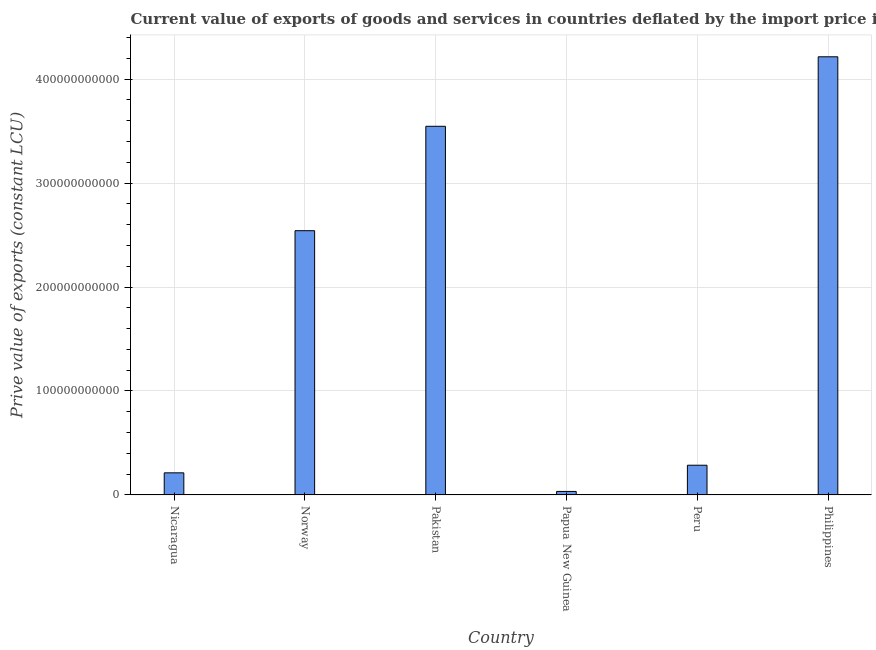What is the title of the graph?
Offer a very short reply. Current value of exports of goods and services in countries deflated by the import price index. What is the label or title of the X-axis?
Ensure brevity in your answer.  Country. What is the label or title of the Y-axis?
Offer a terse response. Prive value of exports (constant LCU). What is the price value of exports in Pakistan?
Make the answer very short. 3.55e+11. Across all countries, what is the maximum price value of exports?
Offer a very short reply. 4.22e+11. Across all countries, what is the minimum price value of exports?
Ensure brevity in your answer.  3.37e+09. In which country was the price value of exports minimum?
Offer a very short reply. Papua New Guinea. What is the sum of the price value of exports?
Provide a succinct answer. 1.08e+12. What is the difference between the price value of exports in Norway and Philippines?
Your response must be concise. -1.67e+11. What is the average price value of exports per country?
Provide a succinct answer. 1.81e+11. What is the median price value of exports?
Ensure brevity in your answer.  1.41e+11. In how many countries, is the price value of exports greater than 360000000000 LCU?
Provide a succinct answer. 1. What is the ratio of the price value of exports in Papua New Guinea to that in Philippines?
Provide a succinct answer. 0.01. What is the difference between the highest and the second highest price value of exports?
Offer a very short reply. 6.69e+1. What is the difference between the highest and the lowest price value of exports?
Offer a very short reply. 4.18e+11. In how many countries, is the price value of exports greater than the average price value of exports taken over all countries?
Ensure brevity in your answer.  3. How many bars are there?
Provide a succinct answer. 6. Are all the bars in the graph horizontal?
Provide a short and direct response. No. What is the difference between two consecutive major ticks on the Y-axis?
Keep it short and to the point. 1.00e+11. Are the values on the major ticks of Y-axis written in scientific E-notation?
Ensure brevity in your answer.  No. What is the Prive value of exports (constant LCU) of Nicaragua?
Your answer should be compact. 2.13e+1. What is the Prive value of exports (constant LCU) of Norway?
Provide a succinct answer. 2.54e+11. What is the Prive value of exports (constant LCU) in Pakistan?
Give a very brief answer. 3.55e+11. What is the Prive value of exports (constant LCU) in Papua New Guinea?
Make the answer very short. 3.37e+09. What is the Prive value of exports (constant LCU) of Peru?
Your answer should be compact. 2.86e+1. What is the Prive value of exports (constant LCU) in Philippines?
Your answer should be very brief. 4.22e+11. What is the difference between the Prive value of exports (constant LCU) in Nicaragua and Norway?
Offer a terse response. -2.33e+11. What is the difference between the Prive value of exports (constant LCU) in Nicaragua and Pakistan?
Provide a short and direct response. -3.33e+11. What is the difference between the Prive value of exports (constant LCU) in Nicaragua and Papua New Guinea?
Provide a succinct answer. 1.79e+1. What is the difference between the Prive value of exports (constant LCU) in Nicaragua and Peru?
Offer a very short reply. -7.32e+09. What is the difference between the Prive value of exports (constant LCU) in Nicaragua and Philippines?
Give a very brief answer. -4.00e+11. What is the difference between the Prive value of exports (constant LCU) in Norway and Pakistan?
Provide a succinct answer. -1.00e+11. What is the difference between the Prive value of exports (constant LCU) in Norway and Papua New Guinea?
Your answer should be compact. 2.51e+11. What is the difference between the Prive value of exports (constant LCU) in Norway and Peru?
Give a very brief answer. 2.26e+11. What is the difference between the Prive value of exports (constant LCU) in Norway and Philippines?
Offer a terse response. -1.67e+11. What is the difference between the Prive value of exports (constant LCU) in Pakistan and Papua New Guinea?
Offer a very short reply. 3.51e+11. What is the difference between the Prive value of exports (constant LCU) in Pakistan and Peru?
Your answer should be compact. 3.26e+11. What is the difference between the Prive value of exports (constant LCU) in Pakistan and Philippines?
Your answer should be compact. -6.69e+1. What is the difference between the Prive value of exports (constant LCU) in Papua New Guinea and Peru?
Offer a very short reply. -2.52e+1. What is the difference between the Prive value of exports (constant LCU) in Papua New Guinea and Philippines?
Offer a terse response. -4.18e+11. What is the difference between the Prive value of exports (constant LCU) in Peru and Philippines?
Your response must be concise. -3.93e+11. What is the ratio of the Prive value of exports (constant LCU) in Nicaragua to that in Norway?
Offer a terse response. 0.08. What is the ratio of the Prive value of exports (constant LCU) in Nicaragua to that in Pakistan?
Give a very brief answer. 0.06. What is the ratio of the Prive value of exports (constant LCU) in Nicaragua to that in Papua New Guinea?
Offer a terse response. 6.31. What is the ratio of the Prive value of exports (constant LCU) in Nicaragua to that in Peru?
Give a very brief answer. 0.74. What is the ratio of the Prive value of exports (constant LCU) in Norway to that in Pakistan?
Provide a succinct answer. 0.72. What is the ratio of the Prive value of exports (constant LCU) in Norway to that in Papua New Guinea?
Offer a very short reply. 75.46. What is the ratio of the Prive value of exports (constant LCU) in Norway to that in Peru?
Provide a succinct answer. 8.9. What is the ratio of the Prive value of exports (constant LCU) in Norway to that in Philippines?
Your response must be concise. 0.6. What is the ratio of the Prive value of exports (constant LCU) in Pakistan to that in Papua New Guinea?
Make the answer very short. 105.27. What is the ratio of the Prive value of exports (constant LCU) in Pakistan to that in Peru?
Keep it short and to the point. 12.41. What is the ratio of the Prive value of exports (constant LCU) in Pakistan to that in Philippines?
Offer a very short reply. 0.84. What is the ratio of the Prive value of exports (constant LCU) in Papua New Guinea to that in Peru?
Provide a short and direct response. 0.12. What is the ratio of the Prive value of exports (constant LCU) in Papua New Guinea to that in Philippines?
Ensure brevity in your answer.  0.01. What is the ratio of the Prive value of exports (constant LCU) in Peru to that in Philippines?
Your answer should be compact. 0.07. 